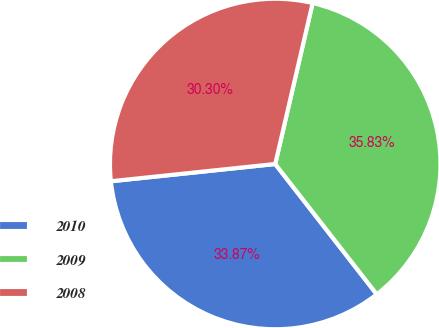Convert chart. <chart><loc_0><loc_0><loc_500><loc_500><pie_chart><fcel>2010<fcel>2009<fcel>2008<nl><fcel>33.87%<fcel>35.83%<fcel>30.3%<nl></chart> 